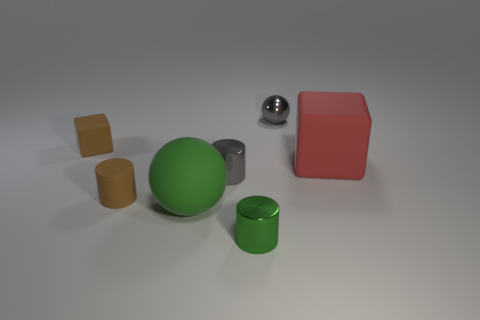What number of objects are either gray shiny things that are in front of the metallic sphere or metallic cylinders that are in front of the tiny gray cylinder?
Provide a succinct answer. 2. There is a brown cube that is the same size as the green metal cylinder; what material is it?
Offer a very short reply. Rubber. What number of other things are there of the same material as the big ball
Provide a short and direct response. 3. Does the tiny green metal thing that is in front of the gray metal cylinder have the same shape as the brown object in front of the red rubber block?
Make the answer very short. Yes. What color is the sphere on the left side of the small gray metallic object that is behind the tiny brown object that is behind the big red cube?
Ensure brevity in your answer.  Green. How many other things are the same color as the matte cylinder?
Offer a very short reply. 1. Are there fewer large red blocks than small cylinders?
Offer a terse response. Yes. What color is the object that is both behind the red rubber cube and to the right of the green cylinder?
Give a very brief answer. Gray. There is a brown thing that is the same shape as the small green metallic object; what material is it?
Your answer should be very brief. Rubber. Is there any other thing that is the same size as the red object?
Keep it short and to the point. Yes. 